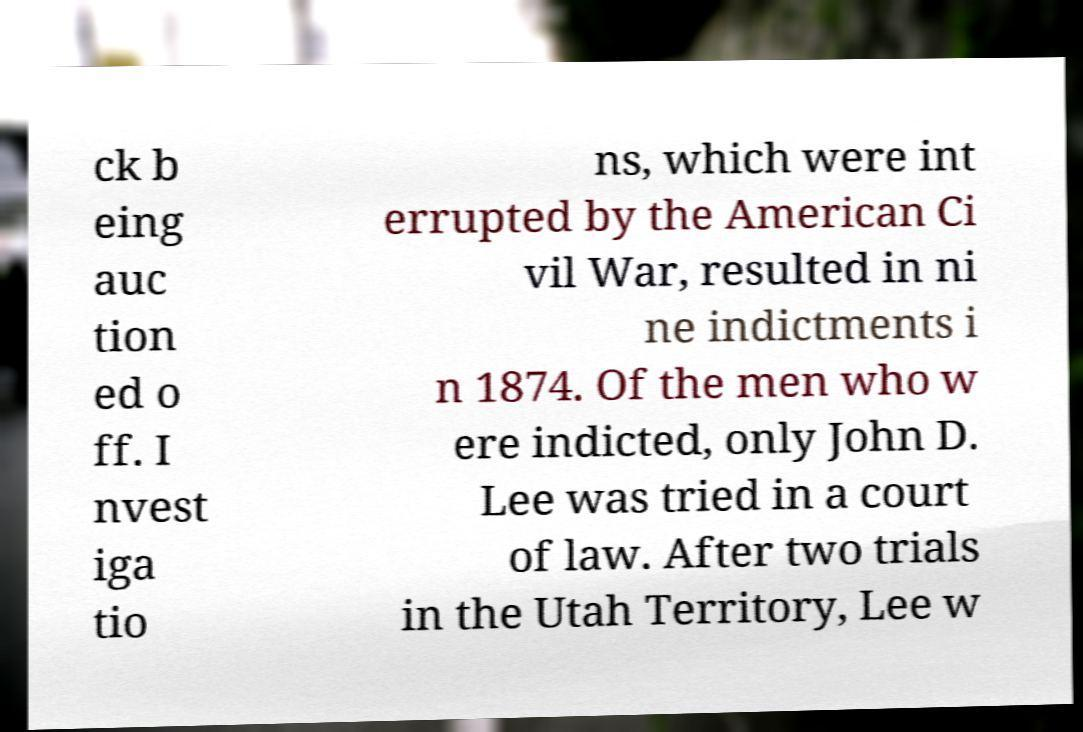Can you read and provide the text displayed in the image?This photo seems to have some interesting text. Can you extract and type it out for me? ck b eing auc tion ed o ff. I nvest iga tio ns, which were int errupted by the American Ci vil War, resulted in ni ne indictments i n 1874. Of the men who w ere indicted, only John D. Lee was tried in a court of law. After two trials in the Utah Territory, Lee w 